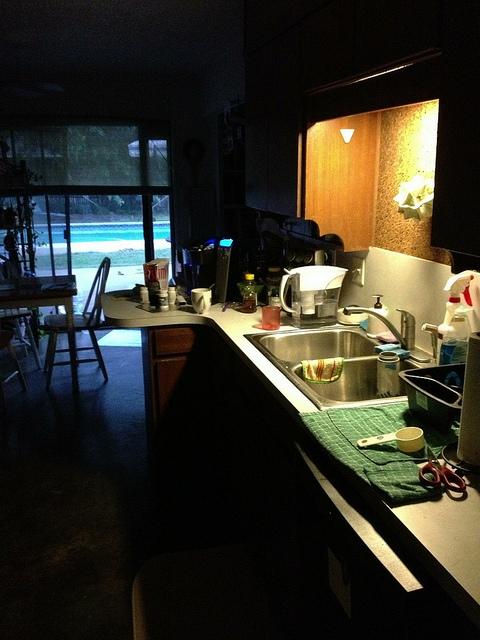What is the item on the green towel for?
Answer briefly. Measuring. Are there dirty dishes in the sink?
Keep it brief. No. Are the candles on the table lit?
Answer briefly. No. Is a pool outside?
Write a very short answer. Yes. 